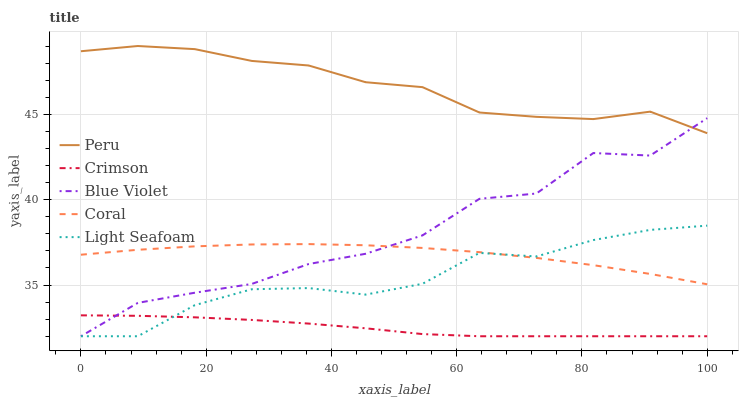Does Crimson have the minimum area under the curve?
Answer yes or no. Yes. Does Peru have the maximum area under the curve?
Answer yes or no. Yes. Does Coral have the minimum area under the curve?
Answer yes or no. No. Does Coral have the maximum area under the curve?
Answer yes or no. No. Is Crimson the smoothest?
Answer yes or no. Yes. Is Blue Violet the roughest?
Answer yes or no. Yes. Is Coral the smoothest?
Answer yes or no. No. Is Coral the roughest?
Answer yes or no. No. Does Crimson have the lowest value?
Answer yes or no. Yes. Does Coral have the lowest value?
Answer yes or no. No. Does Peru have the highest value?
Answer yes or no. Yes. Does Coral have the highest value?
Answer yes or no. No. Is Crimson less than Peru?
Answer yes or no. Yes. Is Peru greater than Coral?
Answer yes or no. Yes. Does Blue Violet intersect Light Seafoam?
Answer yes or no. Yes. Is Blue Violet less than Light Seafoam?
Answer yes or no. No. Is Blue Violet greater than Light Seafoam?
Answer yes or no. No. Does Crimson intersect Peru?
Answer yes or no. No. 